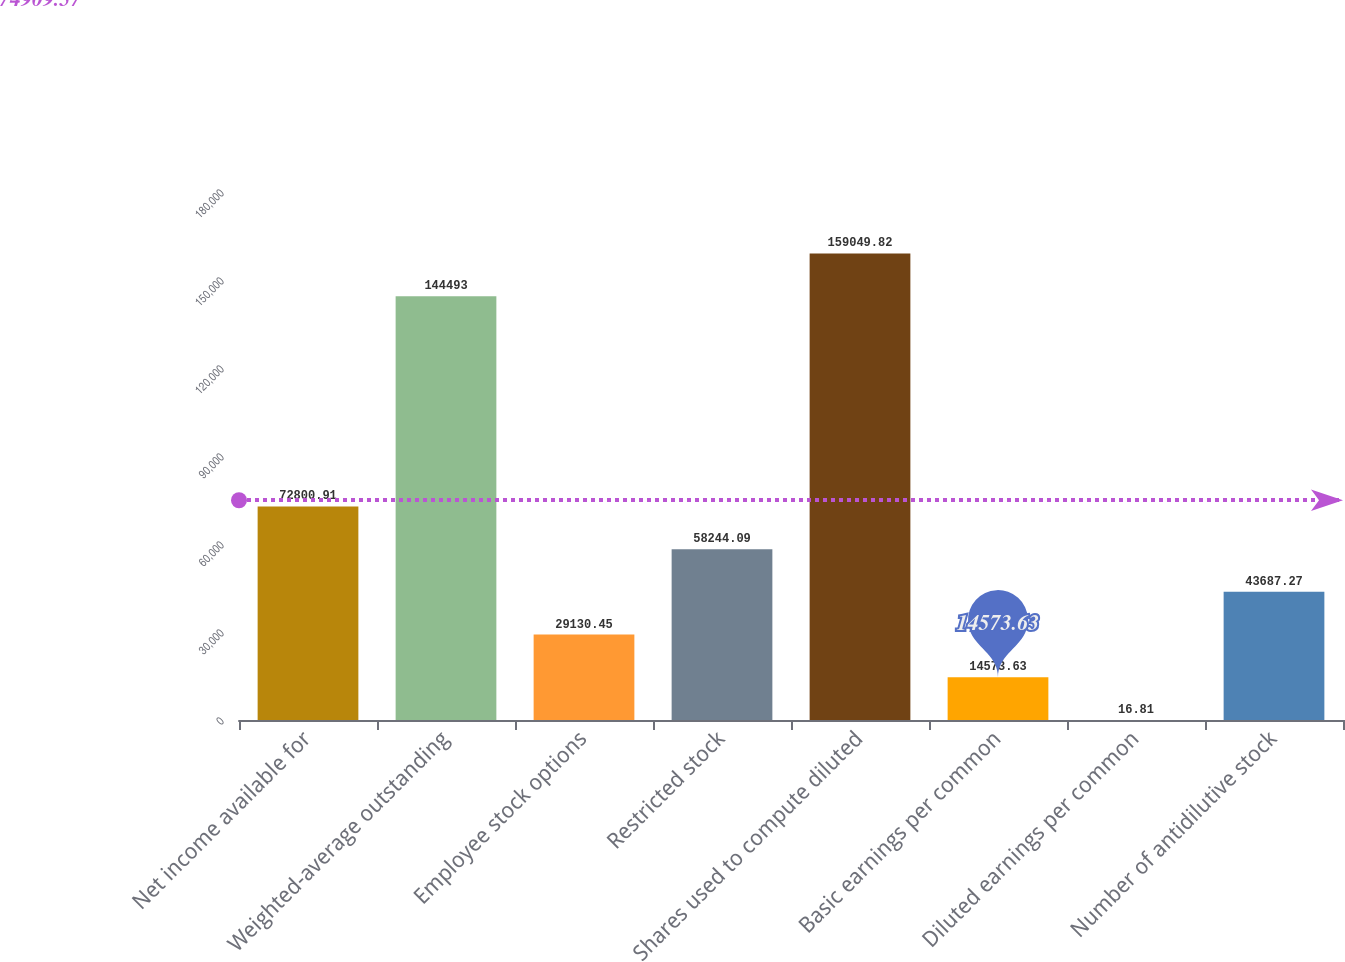Convert chart. <chart><loc_0><loc_0><loc_500><loc_500><bar_chart><fcel>Net income available for<fcel>Weighted-average outstanding<fcel>Employee stock options<fcel>Restricted stock<fcel>Shares used to compute diluted<fcel>Basic earnings per common<fcel>Diluted earnings per common<fcel>Number of antidilutive stock<nl><fcel>72800.9<fcel>144493<fcel>29130.5<fcel>58244.1<fcel>159050<fcel>14573.6<fcel>16.81<fcel>43687.3<nl></chart> 